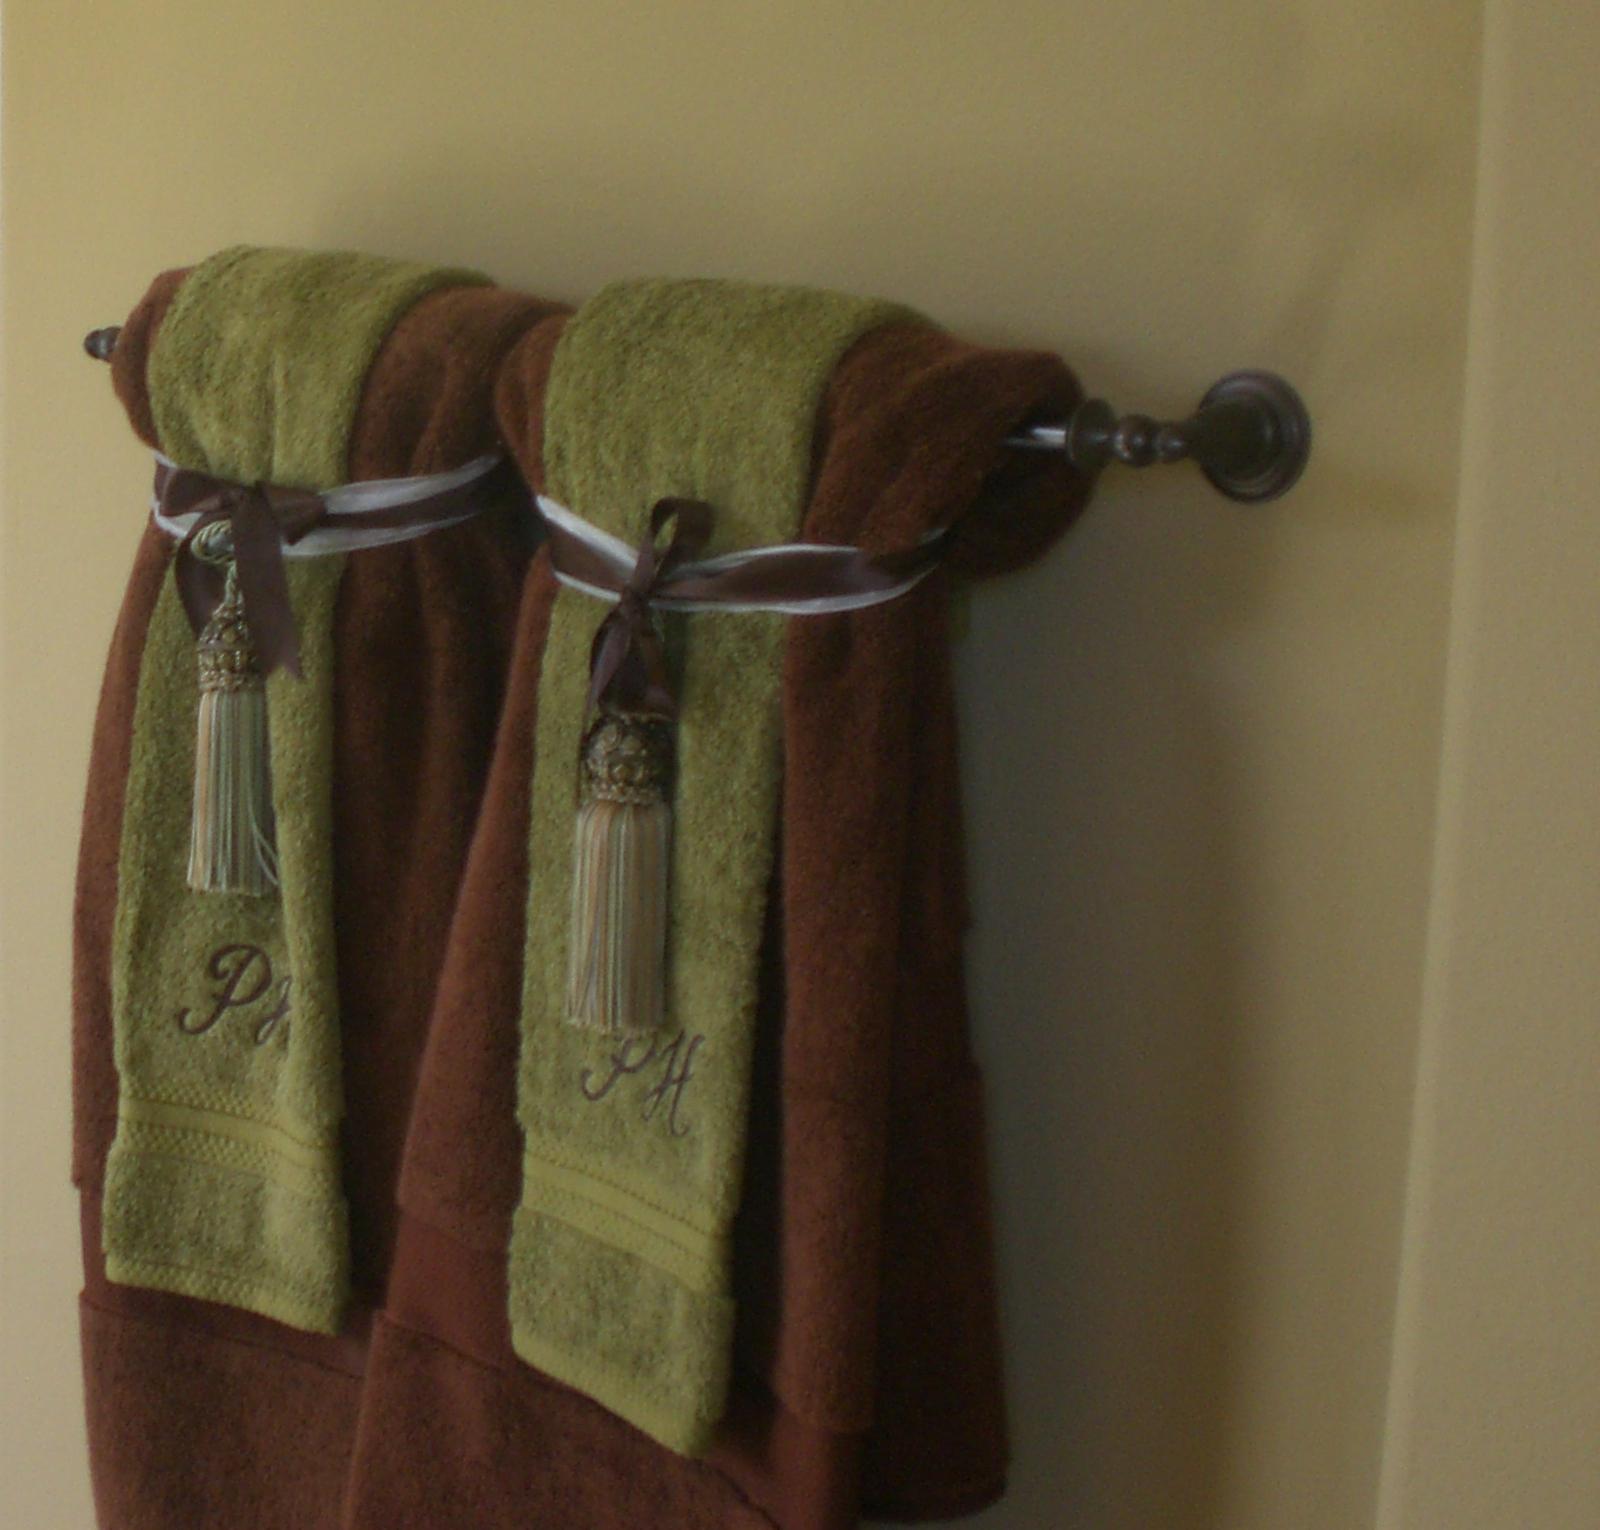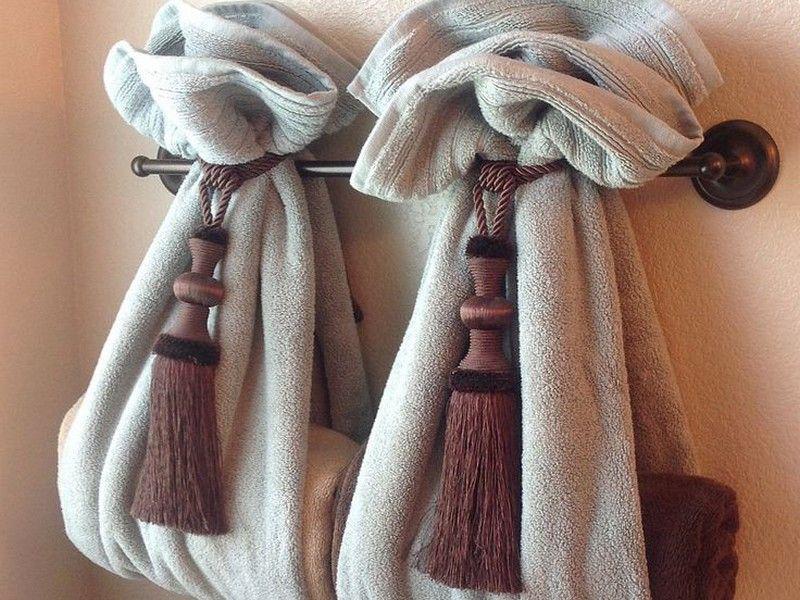The first image is the image on the left, the second image is the image on the right. Assess this claim about the two images: "The left and right image contains the same number of rows of tie towels.". Correct or not? Answer yes or no. Yes. 